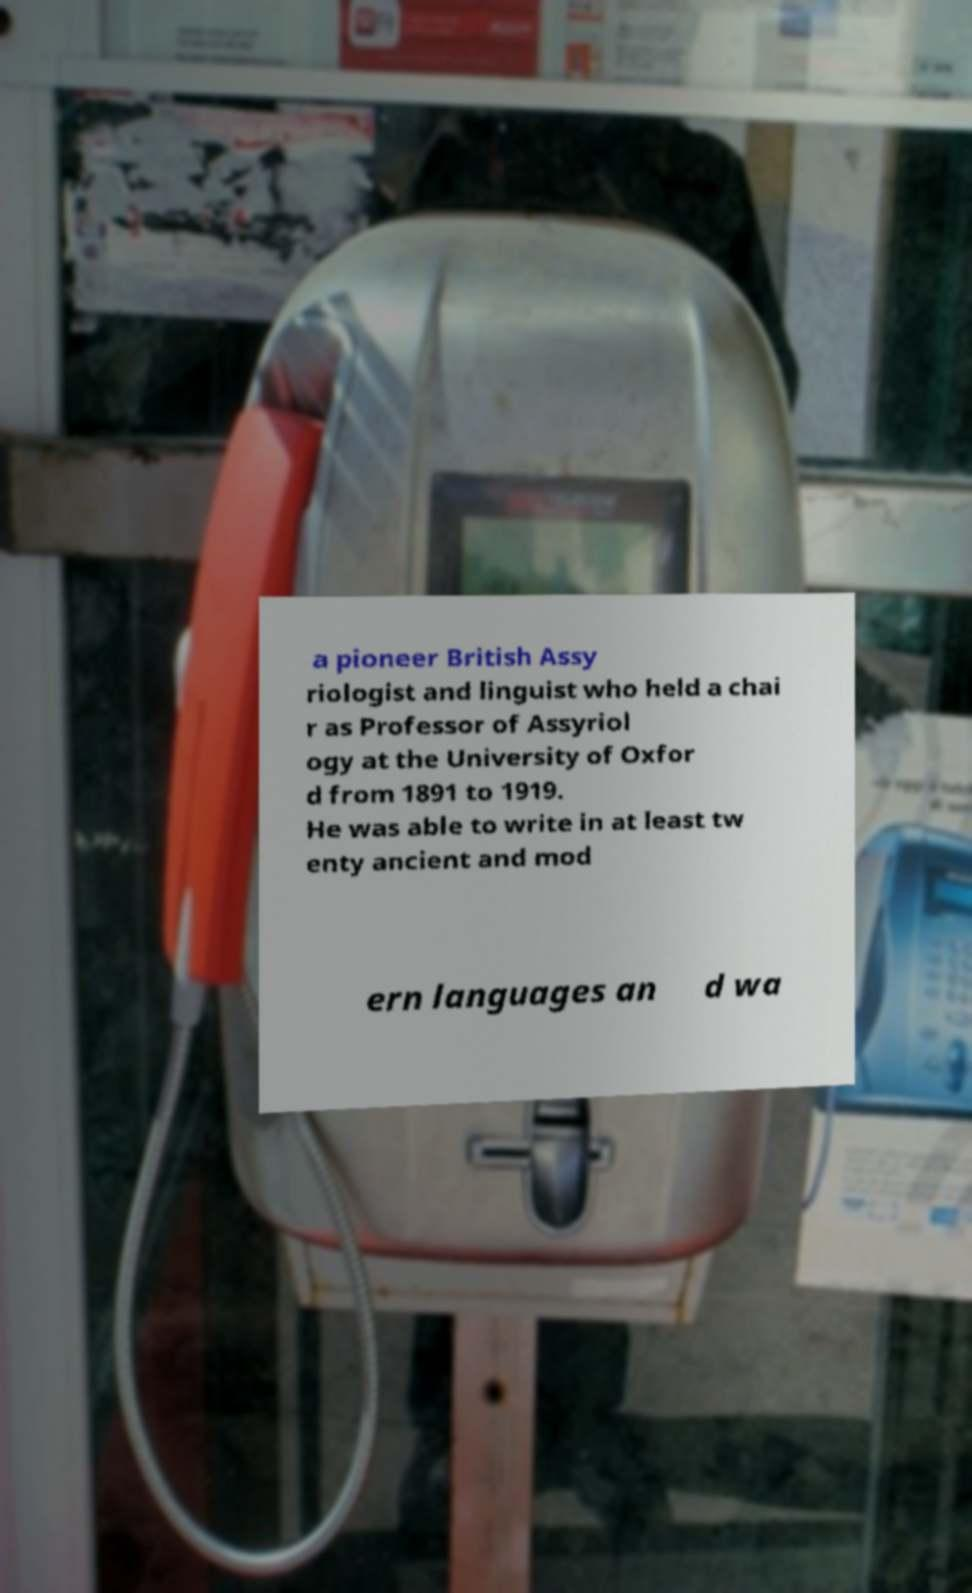For documentation purposes, I need the text within this image transcribed. Could you provide that? a pioneer British Assy riologist and linguist who held a chai r as Professor of Assyriol ogy at the University of Oxfor d from 1891 to 1919. He was able to write in at least tw enty ancient and mod ern languages an d wa 